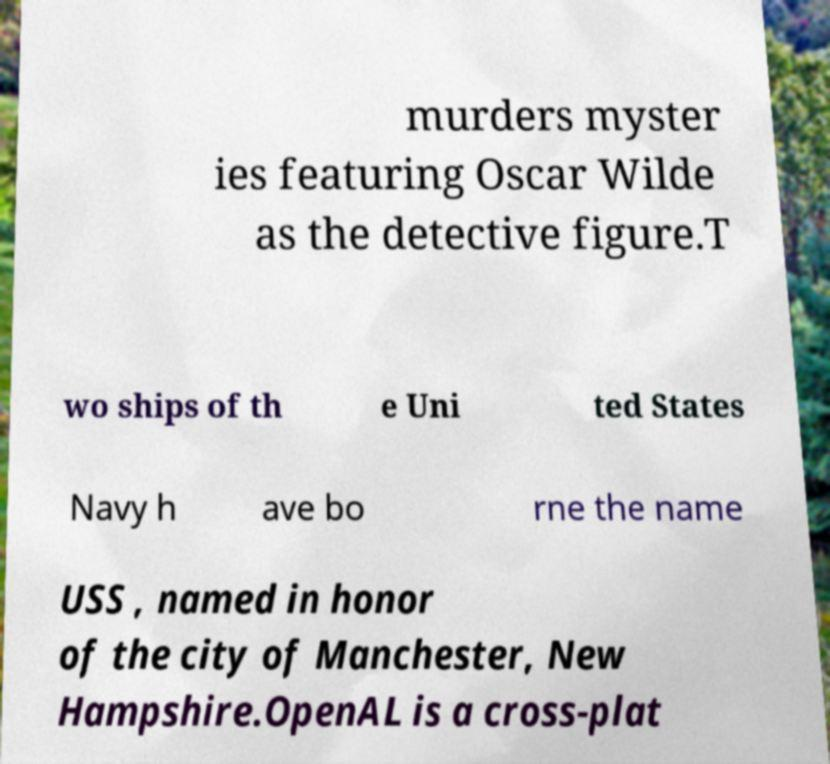Could you assist in decoding the text presented in this image and type it out clearly? murders myster ies featuring Oscar Wilde as the detective figure.T wo ships of th e Uni ted States Navy h ave bo rne the name USS , named in honor of the city of Manchester, New Hampshire.OpenAL is a cross-plat 